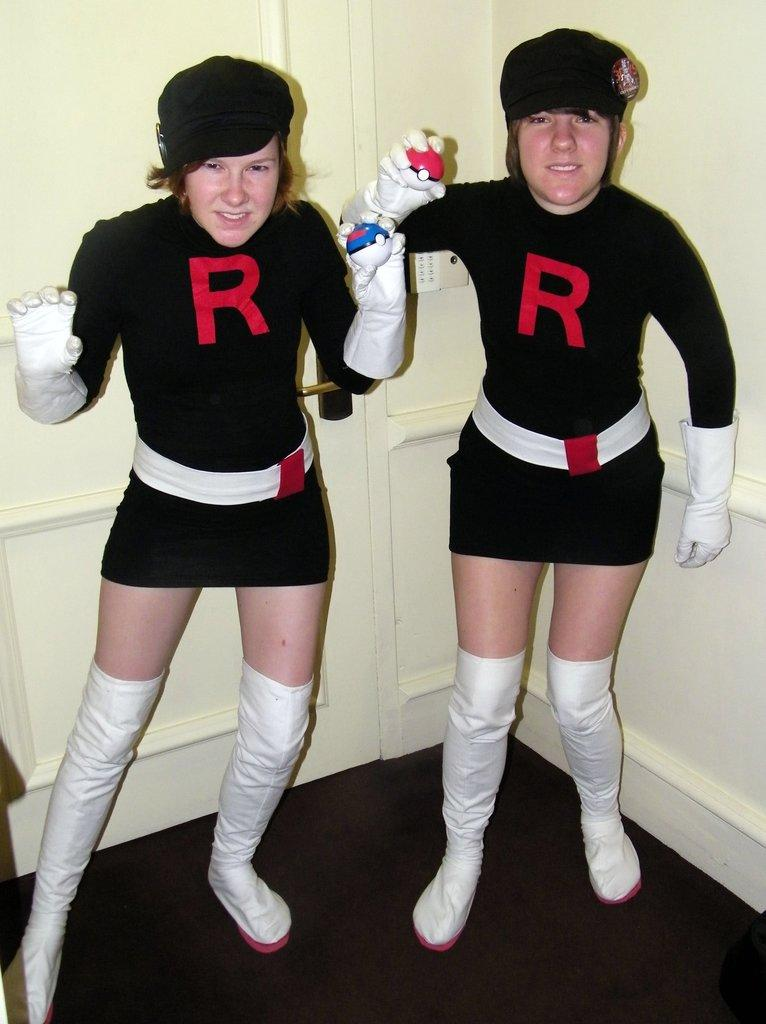How many girls are in the image? There are two girls in the image. What are the girls doing in the image? The girls are standing. What color are the tops the girls are wearing? The girls are wearing black color tops. What color are the shoes the girls are wearing? The girls are wearing white color shoes. What type of clothing are the girls wearing on their hands? The girls are wearing gloves. What can be seen behind the girls in the image? There is a wooden wall behind the girls. What type of parcel is the girl holding in the image? There is no parcel visible in the image. What street can be seen in the background of the image? The image does not show a street or any background elements other than the wooden wall. 